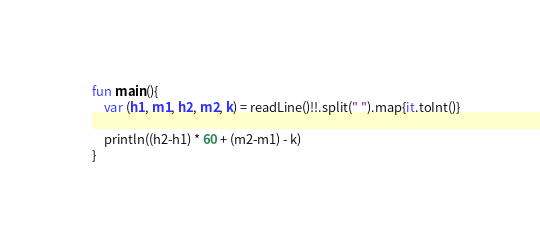Convert code to text. <code><loc_0><loc_0><loc_500><loc_500><_Kotlin_>fun main(){
    var (h1, m1, h2, m2, k) = readLine()!!.split(" ").map{it.toInt()}

    println((h2-h1) * 60 + (m2-m1) - k)
}</code> 